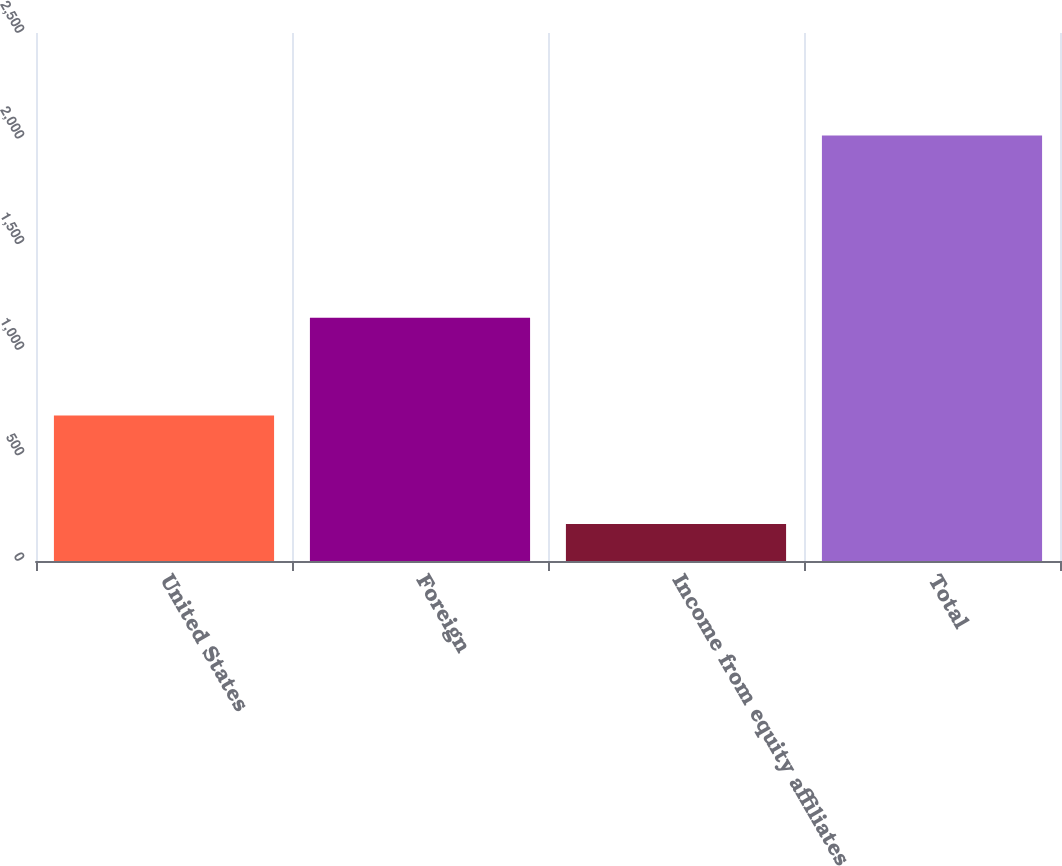<chart> <loc_0><loc_0><loc_500><loc_500><bar_chart><fcel>United States<fcel>Foreign<fcel>Income from equity affiliates<fcel>Total<nl><fcel>688.5<fcel>1151.7<fcel>174.8<fcel>2015<nl></chart> 